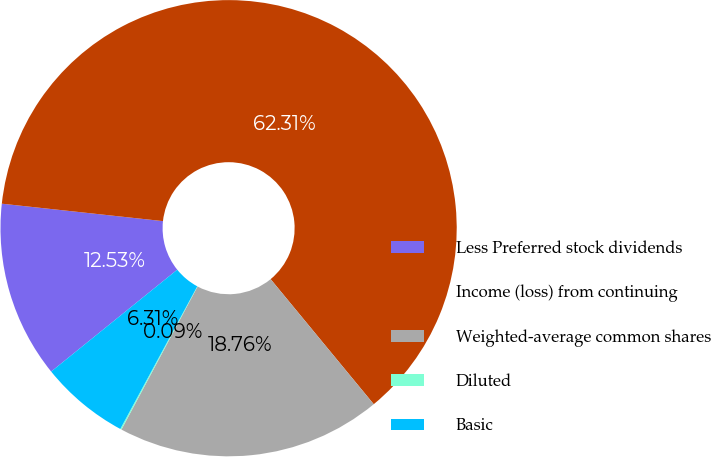<chart> <loc_0><loc_0><loc_500><loc_500><pie_chart><fcel>Less Preferred stock dividends<fcel>Income (loss) from continuing<fcel>Weighted-average common shares<fcel>Diluted<fcel>Basic<nl><fcel>12.53%<fcel>62.31%<fcel>18.76%<fcel>0.09%<fcel>6.31%<nl></chart> 